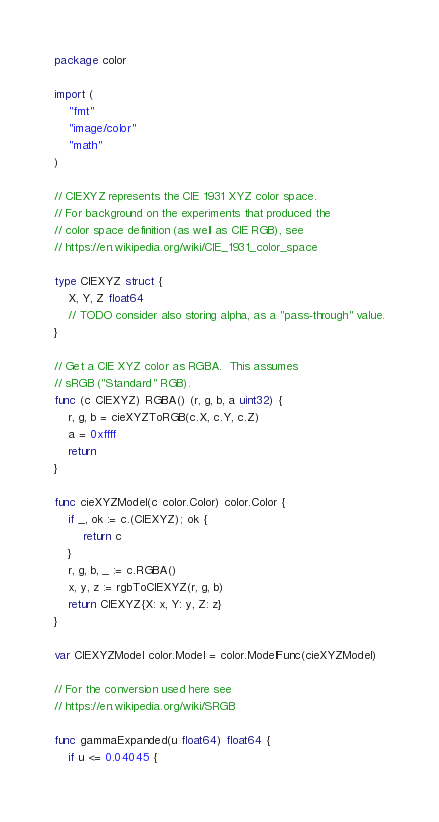<code> <loc_0><loc_0><loc_500><loc_500><_Go_>package color

import (
	"fmt"
	"image/color"
	"math"
)

// CIEXYZ represents the CIE 1931 XYZ color space.
// For background on the experiments that produced the
// color space definition (as well as CIE RGB), see
// https://en.wikipedia.org/wiki/CIE_1931_color_space

type CIEXYZ struct {
	X, Y, Z float64
	// TODO consider also storing alpha, as a "pass-through" value.
}

// Get a CIE XYZ color as RGBA.  This assumes
// sRGB ("Standard" RGB).
func (c CIEXYZ) RGBA() (r, g, b, a uint32) {
	r, g, b = cieXYZToRGB(c.X, c.Y, c.Z)
	a = 0xffff
	return
}

func cieXYZModel(c color.Color) color.Color {
	if _, ok := c.(CIEXYZ); ok {
		return c
	}
	r, g, b, _ := c.RGBA()
	x, y, z := rgbToCIEXYZ(r, g, b)
	return CIEXYZ{X: x, Y: y, Z: z}
}

var CIEXYZModel color.Model = color.ModelFunc(cieXYZModel)

// For the conversion used here see
// https://en.wikipedia.org/wiki/SRGB

func gammaExpanded(u float64) float64 {
	if u <= 0.04045 {</code> 